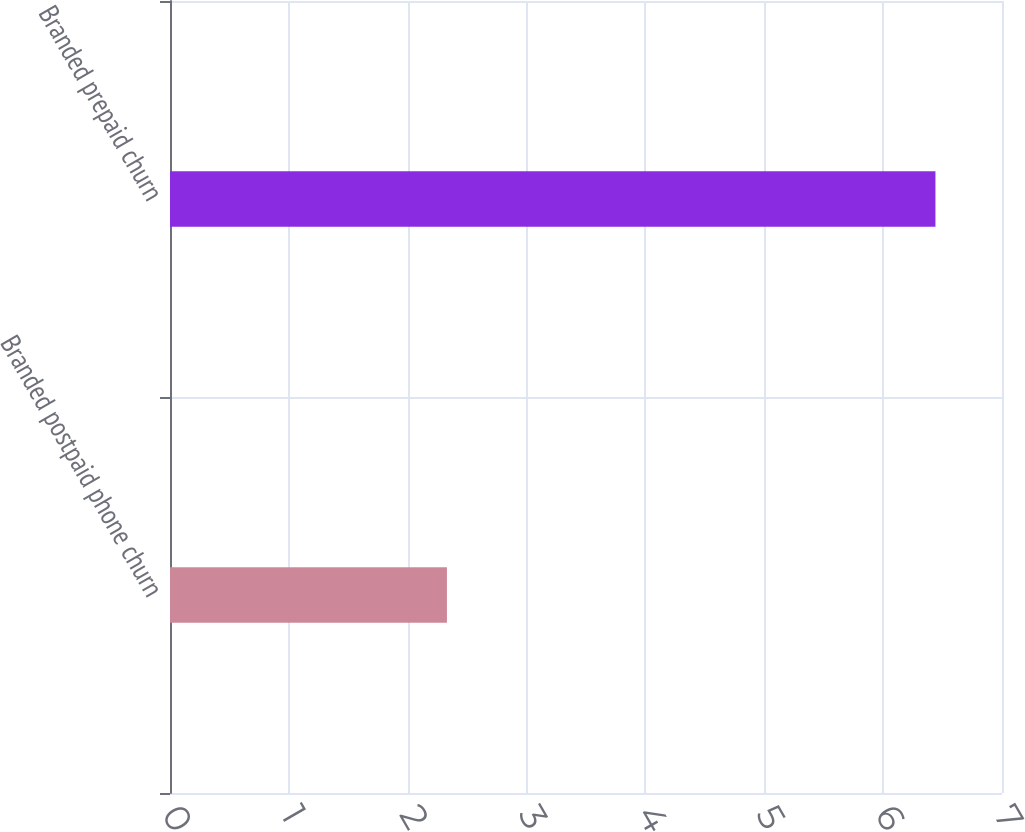Convert chart. <chart><loc_0><loc_0><loc_500><loc_500><bar_chart><fcel>Branded postpaid phone churn<fcel>Branded prepaid churn<nl><fcel>2.33<fcel>6.44<nl></chart> 